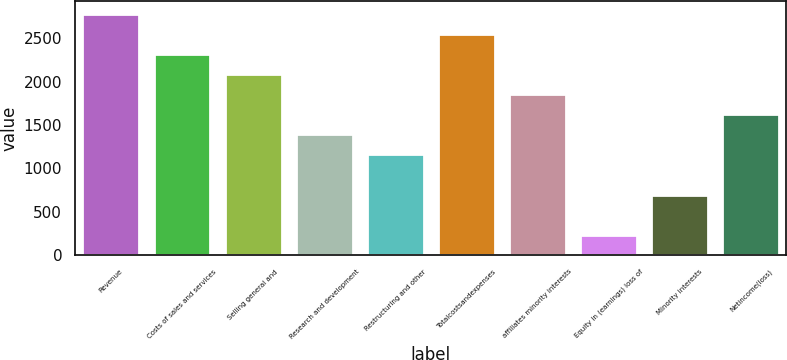<chart> <loc_0><loc_0><loc_500><loc_500><bar_chart><fcel>Revenue<fcel>Costs of sales and services<fcel>Selling general and<fcel>Research and development<fcel>Restructuring and other<fcel>Totalcostsandexpenses<fcel>affiliates minority interests<fcel>Equity in (earnings) loss of<fcel>Minority interests<fcel>Netincome(loss)<nl><fcel>2784.27<fcel>2320.51<fcel>2088.63<fcel>1392.99<fcel>1161.11<fcel>2552.39<fcel>1856.75<fcel>233.59<fcel>697.35<fcel>1624.87<nl></chart> 